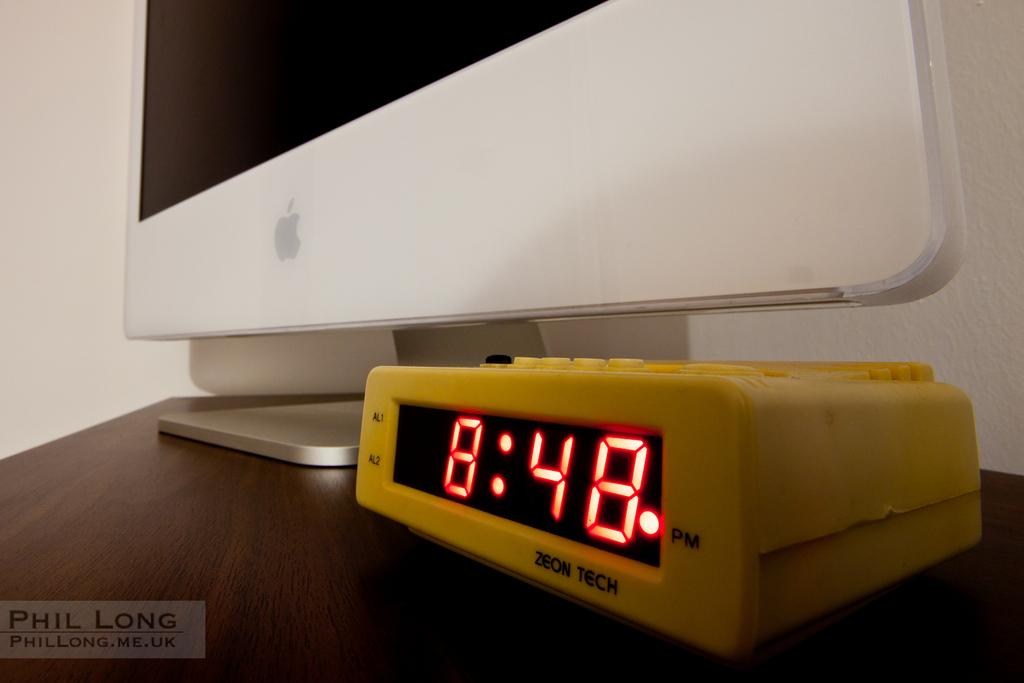<image>
Render a clear and concise summary of the photo. The time on the clock reads 848 pm 